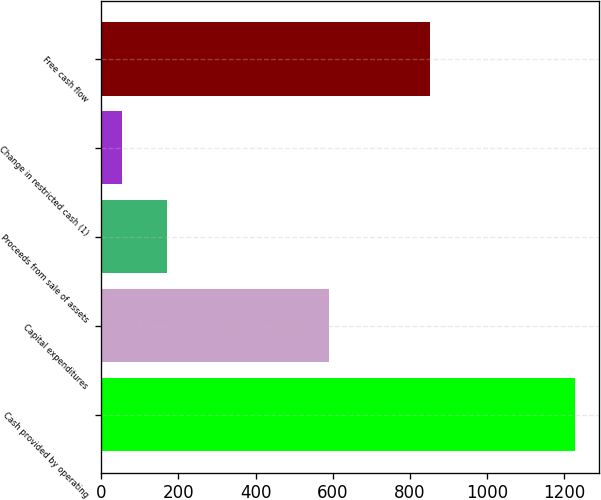Convert chart to OTSL. <chart><loc_0><loc_0><loc_500><loc_500><bar_chart><fcel>Cash provided by operating<fcel>Capital expenditures<fcel>Proceeds from sale of assets<fcel>Change in restricted cash (1)<fcel>Free cash flow<nl><fcel>1229<fcel>590<fcel>171.5<fcel>54<fcel>853<nl></chart> 